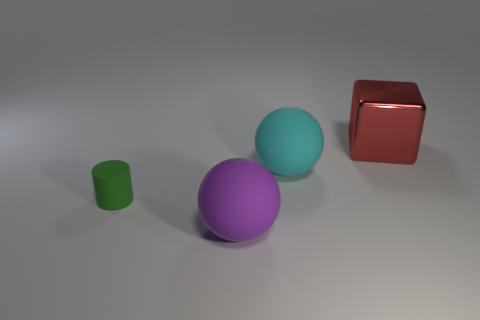Add 1 large rubber balls. How many objects exist? 5 Subtract all blocks. How many objects are left? 3 Subtract all purple balls. Subtract all big purple rubber spheres. How many objects are left? 2 Add 4 red metallic objects. How many red metallic objects are left? 5 Add 4 tiny cyan rubber blocks. How many tiny cyan rubber blocks exist? 4 Subtract 0 green balls. How many objects are left? 4 